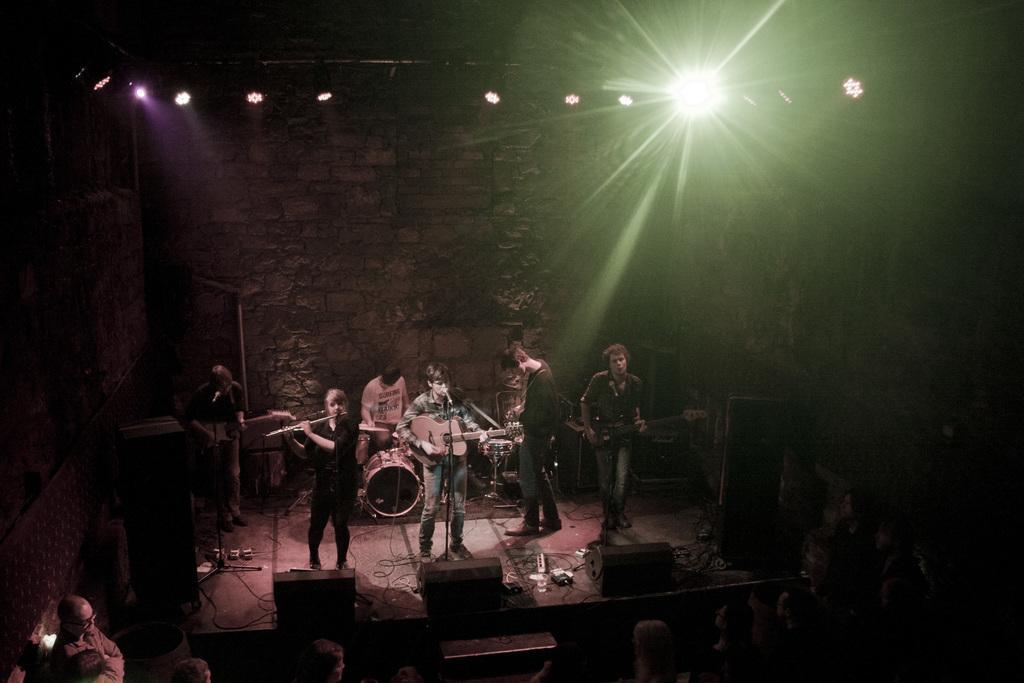How would you summarize this image in a sentence or two? In the image we can see there are people who are holding guitar, flute and playing drums on the stage and the people are watching them. 